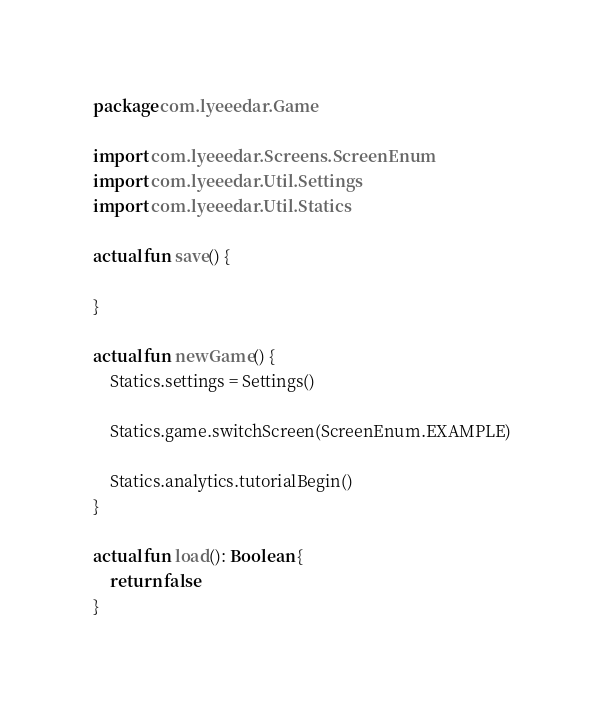<code> <loc_0><loc_0><loc_500><loc_500><_Kotlin_>package com.lyeeedar.Game

import com.lyeeedar.Screens.ScreenEnum
import com.lyeeedar.Util.Settings
import com.lyeeedar.Util.Statics

actual fun save() {

}

actual fun newGame() {
	Statics.settings = Settings()

	Statics.game.switchScreen(ScreenEnum.EXAMPLE)

	Statics.analytics.tutorialBegin()
}

actual fun load(): Boolean {
	return false
}</code> 